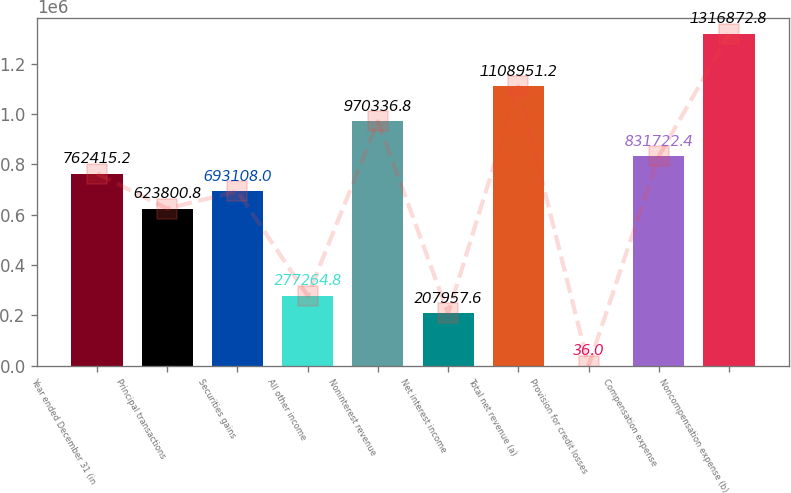Convert chart to OTSL. <chart><loc_0><loc_0><loc_500><loc_500><bar_chart><fcel>Year ended December 31 (in<fcel>Principal transactions<fcel>Securities gains<fcel>All other income<fcel>Noninterest revenue<fcel>Net interest income<fcel>Total net revenue (a)<fcel>Provision for credit losses<fcel>Compensation expense<fcel>Noncompensation expense (b)<nl><fcel>762415<fcel>623801<fcel>693108<fcel>277265<fcel>970337<fcel>207958<fcel>1.10895e+06<fcel>36<fcel>831722<fcel>1.31687e+06<nl></chart> 